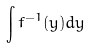Convert formula to latex. <formula><loc_0><loc_0><loc_500><loc_500>\int f ^ { - 1 } ( y ) d y</formula> 